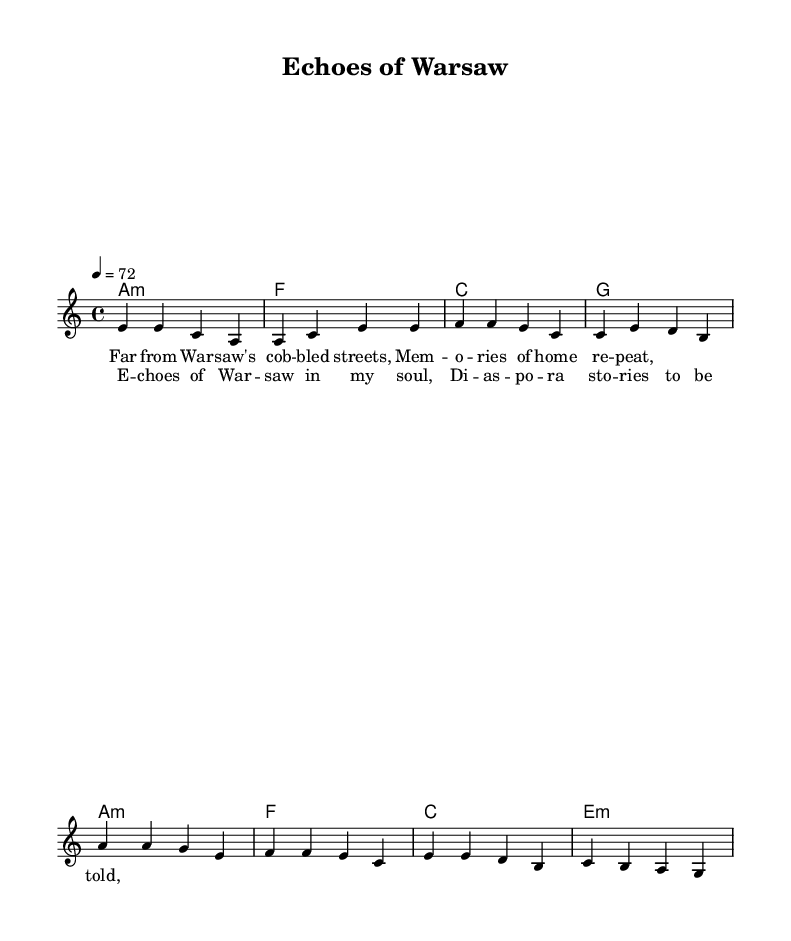What is the key signature of this music? The key signature shows that this piece is in A minor, which has no sharps or flats.
Answer: A minor What is the time signature of this music? The time signature indicates that there are four beats in each measure, as denoted by 4/4.
Answer: 4/4 What is the tempo marking for the piece? The tempo marking specifies that the piece should be played at a speed of 72 beats per minute, indicated by the note "4 = 72."
Answer: 72 What are the primary chords used in the verses? The chords used in the verses are A minor, F major, C major, and G major, as seen in the chord progression listed under the verse section.
Answer: A minor, F, C, G How does the chorus melody differ from the verse melody? The chorus melody is established with slightly different pitch patterns and rhythmic emphasis compared to the verse, such as starting on A and having downward movement to G.
Answer: Different pitch patterns What themes are reflected in the lyrics of the song? The lyrics explore themes of nostalgia, memory, and the experience of displacement, evident from the references to Warsaw and diaspora in the chorus.
Answer: Nostalgia and exile What is the significance of the title "Echoes of Warsaw"? The title suggests a connection between the past and present, highlighting the emotional resonance of memories from Warsaw, which aligns with themes of exile and displacement.
Answer: Emotional resonance of Warsaw 